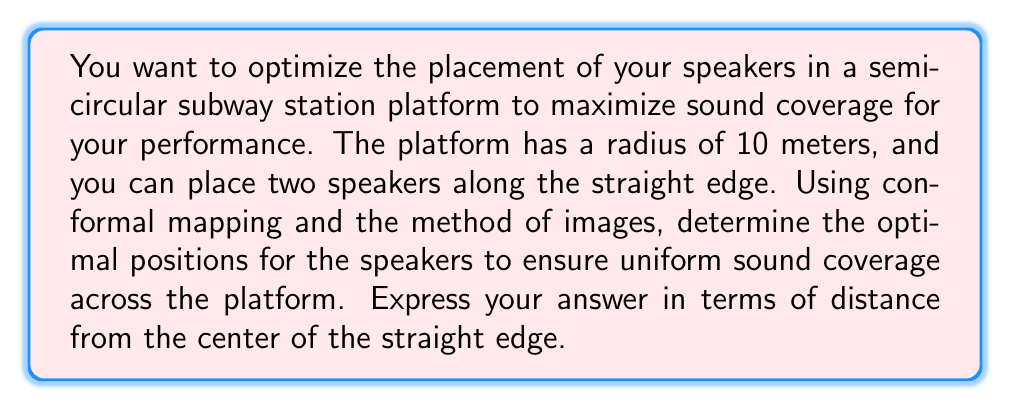Could you help me with this problem? To solve this problem, we'll use conformal mapping and the method of images. Here's a step-by-step approach:

1) First, we need to map the semicircular region to the upper half-plane. The conformal map that does this is:

   $$w = \frac{z-i}{z+i}$$

   where $z$ is a point in the semicircular region and $w$ is the corresponding point in the upper half-plane.

2) The straight edge of the semicircle maps to the real axis in the $w$-plane.

3) In the method of images, we want to place the speakers such that their images (reflections across the real axis) form an equilateral triangle with the point at infinity.

4) In the $w$-plane, this means we want to place the speakers at $w_1 = e^{i\pi/3}$ and $w_2 = e^{-i\pi/3}$.

5) Now we need to map these points back to the $z$-plane. We can use the inverse of our original conformal map:

   $$z = i\frac{1+w}{1-w}$$

6) Substituting $w_1 = e^{i\pi/3}$:

   $$z_1 = i\frac{1+e^{i\pi/3}}{1-e^{i\pi/3}} = i\frac{1+(\frac{1}{2}+i\frac{\sqrt{3}}{2})}{1-(\frac{1}{2}+i\frac{\sqrt{3}}{2})} = i\frac{(\frac{3}{2}+i\frac{\sqrt{3}}{2})}{(\frac{1}{2}-i\frac{\sqrt{3}}{2})} = \sqrt{3}$$

7) Due to symmetry, $z_2 = -\sqrt{3}$.

8) These $z$ values are in units of the radius. Since our platform has a radius of 10 meters, the optimal positions are at $\pm 10\sqrt{3}$ meters from the center of the straight edge.
Answer: The optimal positions for the speakers are $10\sqrt{3} \approx 17.32$ meters to the left and right of the center of the straight edge of the platform. 